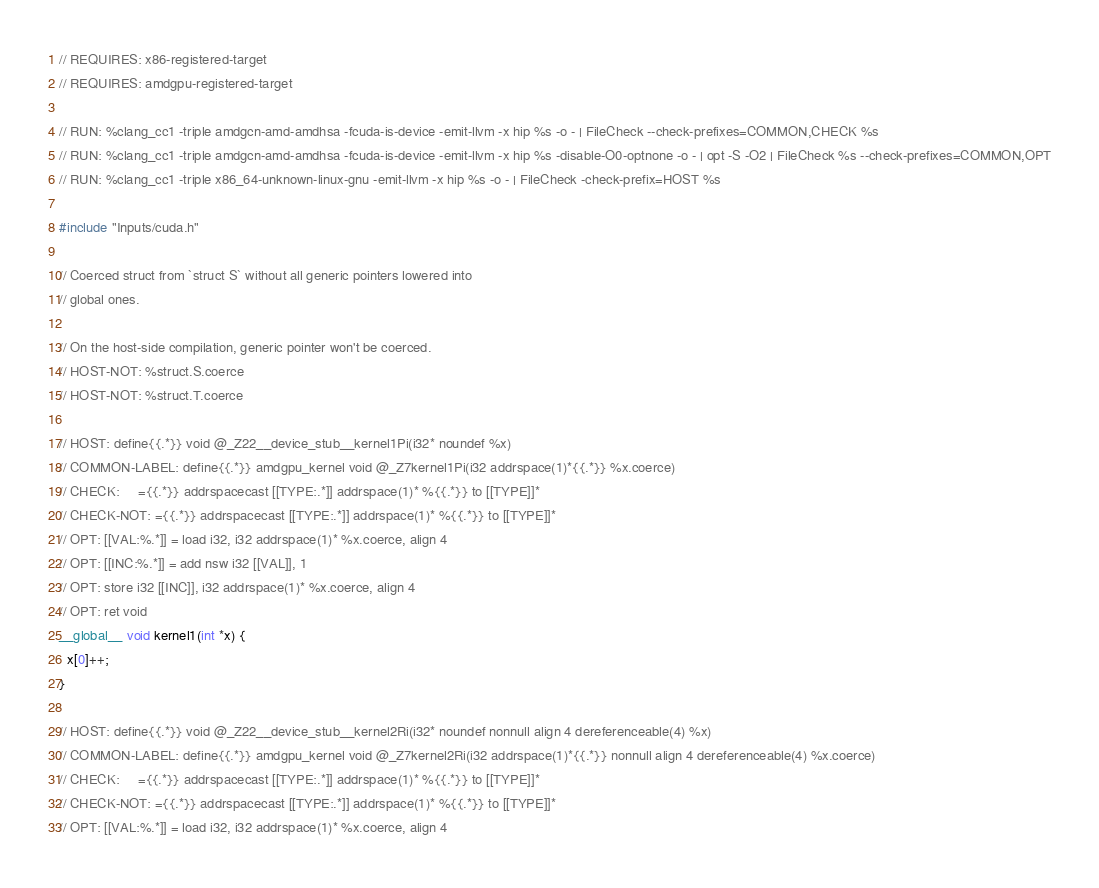Convert code to text. <code><loc_0><loc_0><loc_500><loc_500><_Cuda_>// REQUIRES: x86-registered-target
// REQUIRES: amdgpu-registered-target

// RUN: %clang_cc1 -triple amdgcn-amd-amdhsa -fcuda-is-device -emit-llvm -x hip %s -o - | FileCheck --check-prefixes=COMMON,CHECK %s
// RUN: %clang_cc1 -triple amdgcn-amd-amdhsa -fcuda-is-device -emit-llvm -x hip %s -disable-O0-optnone -o - | opt -S -O2 | FileCheck %s --check-prefixes=COMMON,OPT
// RUN: %clang_cc1 -triple x86_64-unknown-linux-gnu -emit-llvm -x hip %s -o - | FileCheck -check-prefix=HOST %s

#include "Inputs/cuda.h"

// Coerced struct from `struct S` without all generic pointers lowered into
// global ones.

// On the host-side compilation, generic pointer won't be coerced.
// HOST-NOT: %struct.S.coerce
// HOST-NOT: %struct.T.coerce

// HOST: define{{.*}} void @_Z22__device_stub__kernel1Pi(i32* noundef %x)
// COMMON-LABEL: define{{.*}} amdgpu_kernel void @_Z7kernel1Pi(i32 addrspace(1)*{{.*}} %x.coerce)
// CHECK:     ={{.*}} addrspacecast [[TYPE:.*]] addrspace(1)* %{{.*}} to [[TYPE]]*
// CHECK-NOT: ={{.*}} addrspacecast [[TYPE:.*]] addrspace(1)* %{{.*}} to [[TYPE]]*
// OPT: [[VAL:%.*]] = load i32, i32 addrspace(1)* %x.coerce, align 4
// OPT: [[INC:%.*]] = add nsw i32 [[VAL]], 1
// OPT: store i32 [[INC]], i32 addrspace(1)* %x.coerce, align 4
// OPT: ret void
__global__ void kernel1(int *x) {
  x[0]++;
}

// HOST: define{{.*}} void @_Z22__device_stub__kernel2Ri(i32* noundef nonnull align 4 dereferenceable(4) %x)
// COMMON-LABEL: define{{.*}} amdgpu_kernel void @_Z7kernel2Ri(i32 addrspace(1)*{{.*}} nonnull align 4 dereferenceable(4) %x.coerce)
// CHECK:     ={{.*}} addrspacecast [[TYPE:.*]] addrspace(1)* %{{.*}} to [[TYPE]]*
// CHECK-NOT: ={{.*}} addrspacecast [[TYPE:.*]] addrspace(1)* %{{.*}} to [[TYPE]]*
// OPT: [[VAL:%.*]] = load i32, i32 addrspace(1)* %x.coerce, align 4</code> 